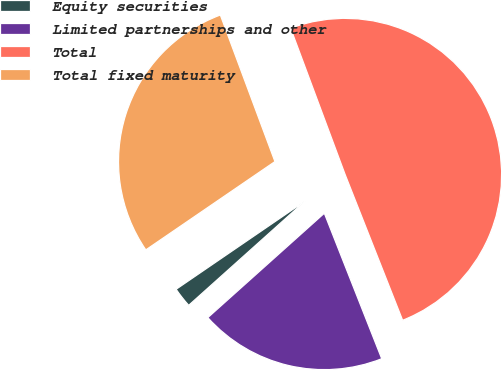Convert chart. <chart><loc_0><loc_0><loc_500><loc_500><pie_chart><fcel>Equity securities<fcel>Limited partnerships and other<fcel>Total<fcel>Total fixed maturity<nl><fcel>2.08%<fcel>19.35%<fcel>49.69%<fcel>28.87%<nl></chart> 